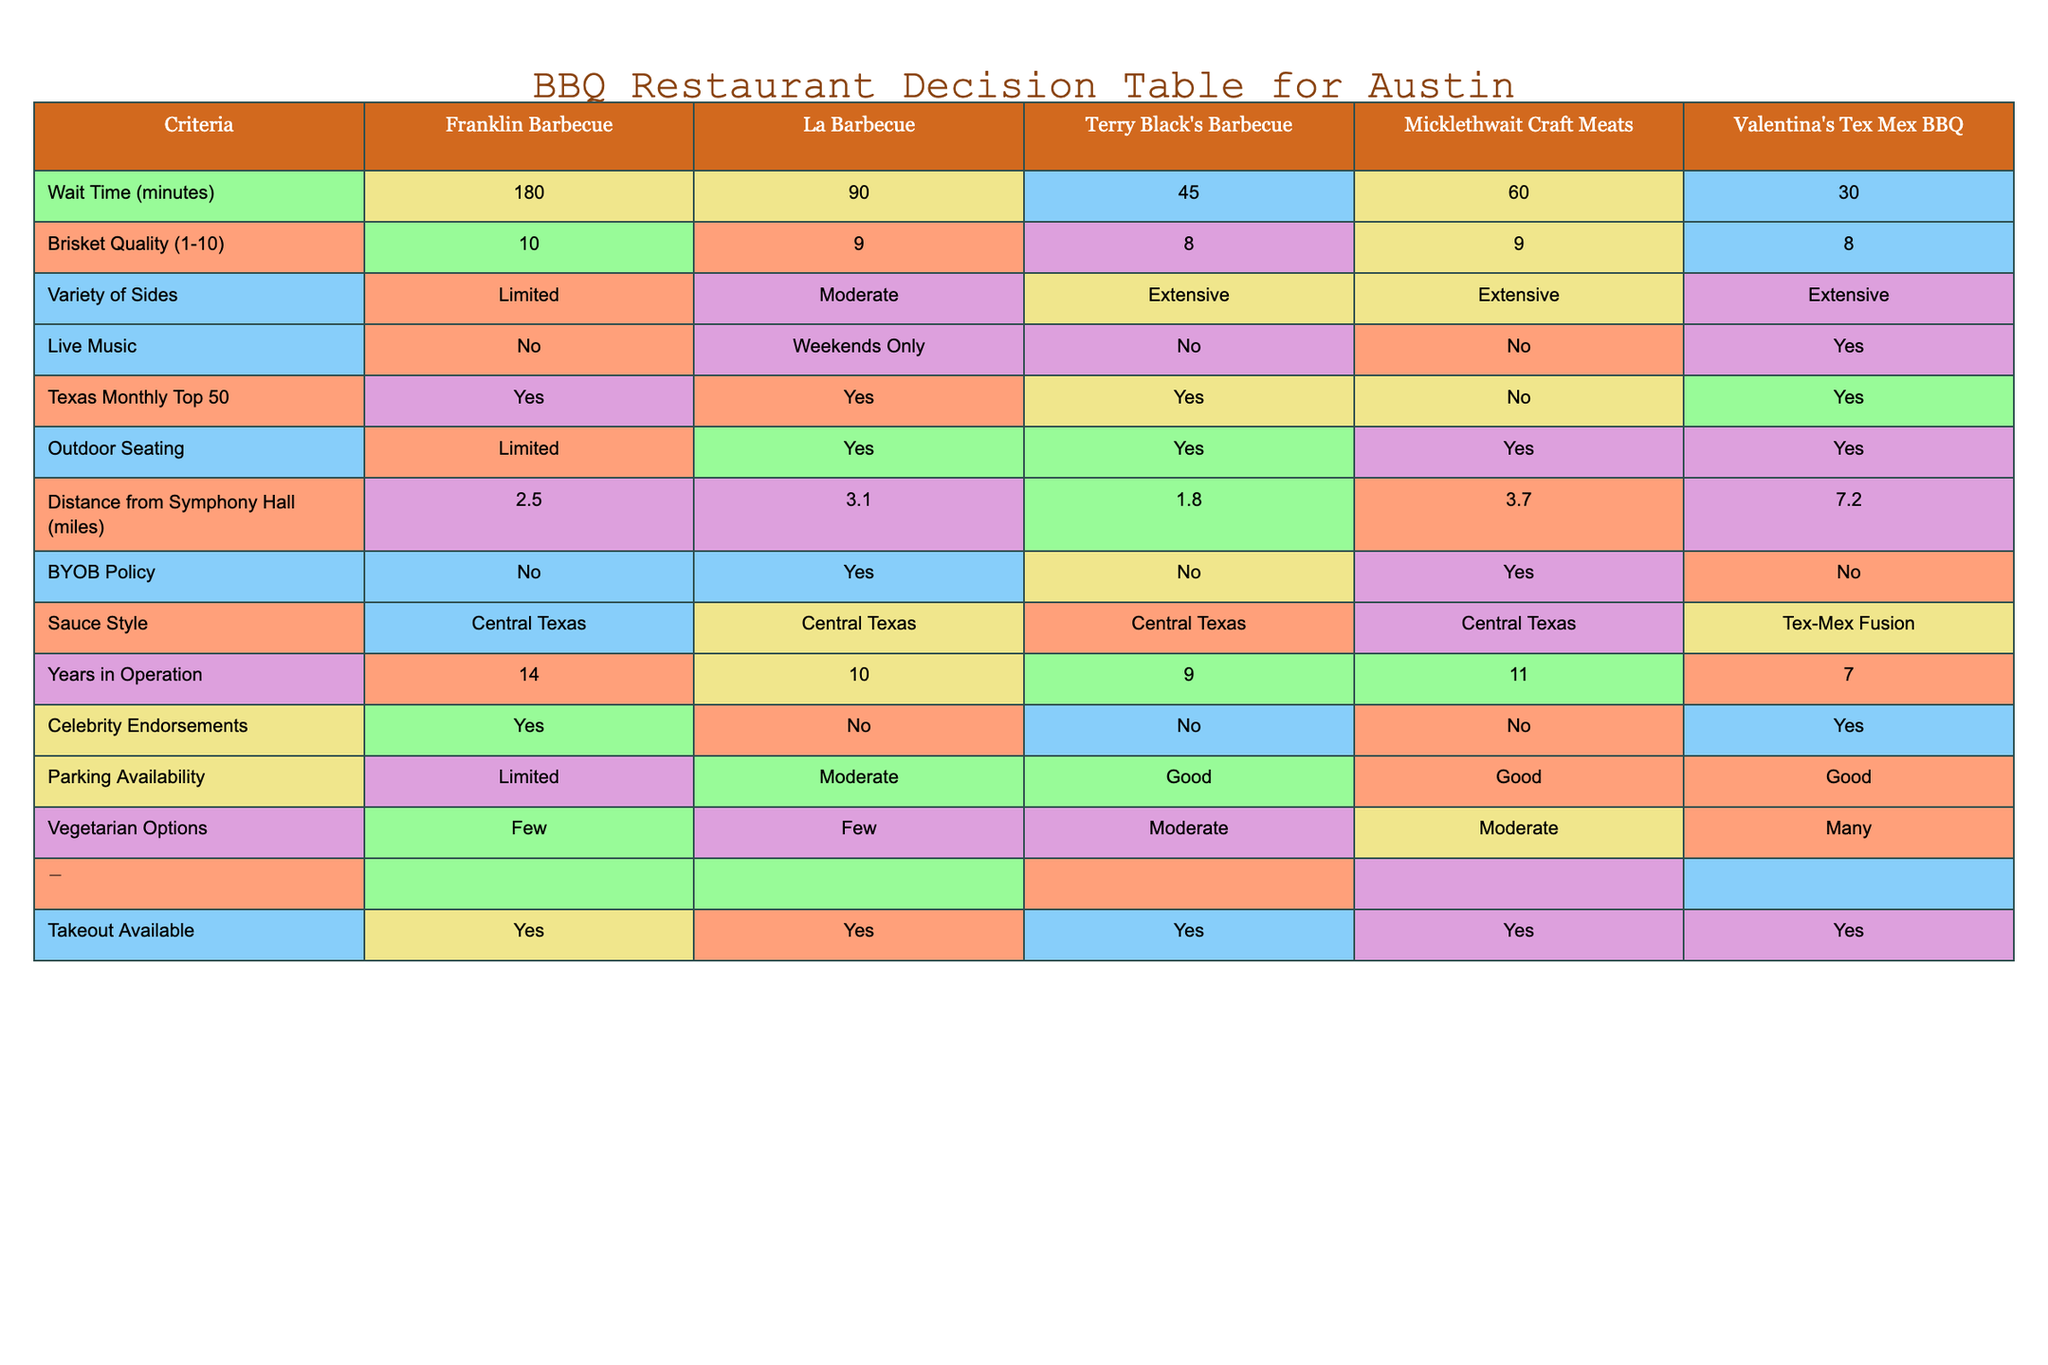What is the wait time at Franklin Barbecue? The table shows that the wait time at Franklin Barbecue is listed as 180 minutes.
Answer: 180 minutes Which BBQ restaurant has the best brisket quality rating? According to the table, Franklin Barbecue has a brisket quality rating of 10, which is the highest among the listed restaurants.
Answer: Franklin Barbecue How many restaurants offer live music? The table shows that only Valentina's Tex Mex BBQ offers live music on a regular basis, while La Barbecue has it only on weekends. Therefore, there are two restaurants that provide live music.
Answer: 2 Which restaurant is the closest to Symphony Hall? The distance from Symphony Hall is provided for each restaurant, and Terry Black's Barbecue has the shortest distance at 1.8 miles.
Answer: Terry Black's Barbecue What is the average wait time of the BBQ restaurants listed in the table? The wait times are 180, 90, 45, 60, and 30 minutes. The total wait time is 180 + 90 + 45 + 60 + 30 = 405 minutes. Dividing by 5 (the number of restaurants), the average wait time is 405/5 = 81 minutes.
Answer: 81 minutes Is there outdoor seating available at Micklethwait Craft Meats? The table states that outdoor seating at Micklethwait Craft Meats is labeled as "Yes."
Answer: Yes Which restaurant has the most extensive variety of sides? Several restaurants have extensive varieties of sides, but the ones listed are Terry Black's Barbecue, Micklethwait Craft Meats, and Valentina's Tex Mex BBQ. Therefore, three restaurants have an extensive variety.
Answer: 3 Do any of the restaurants have a BYOB policy? La Barbecue and Micklethwait Craft Meats both have a BYOB policy as indicated in the table.
Answer: Yes What is the price range of Valentina's Tex Mex BBQ? The table states that the price range for Valentina's Tex Mex BBQ is "$$."
Answer: $$ 